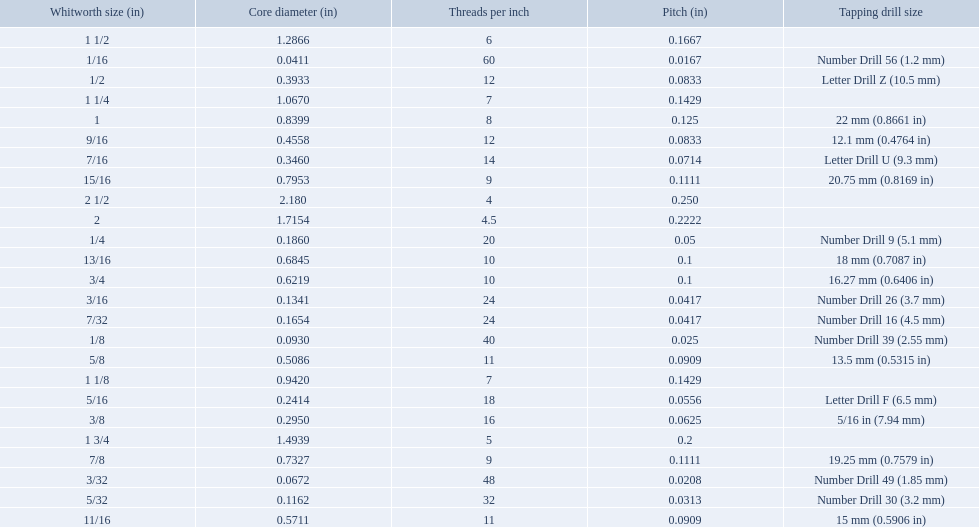What is the core diameter for the number drill 26? 0.1341. What is the whitworth size (in) for this core diameter? 3/16. Parse the full table in json format. {'header': ['Whitworth size (in)', 'Core diameter (in)', 'Threads per\xa0inch', 'Pitch (in)', 'Tapping drill size'], 'rows': [['1 1/2', '1.2866', '6', '0.1667', ''], ['1/16', '0.0411', '60', '0.0167', 'Number Drill 56 (1.2\xa0mm)'], ['1/2', '0.3933', '12', '0.0833', 'Letter Drill Z (10.5\xa0mm)'], ['1 1/4', '1.0670', '7', '0.1429', ''], ['1', '0.8399', '8', '0.125', '22\xa0mm (0.8661\xa0in)'], ['9/16', '0.4558', '12', '0.0833', '12.1\xa0mm (0.4764\xa0in)'], ['7/16', '0.3460', '14', '0.0714', 'Letter Drill U (9.3\xa0mm)'], ['15/16', '0.7953', '9', '0.1111', '20.75\xa0mm (0.8169\xa0in)'], ['2 1/2', '2.180', '4', '0.250', ''], ['2', '1.7154', '4.5', '0.2222', ''], ['1/4', '0.1860', '20', '0.05', 'Number Drill 9 (5.1\xa0mm)'], ['13/16', '0.6845', '10', '0.1', '18\xa0mm (0.7087\xa0in)'], ['3/4', '0.6219', '10', '0.1', '16.27\xa0mm (0.6406\xa0in)'], ['3/16', '0.1341', '24', '0.0417', 'Number Drill 26 (3.7\xa0mm)'], ['7/32', '0.1654', '24', '0.0417', 'Number Drill 16 (4.5\xa0mm)'], ['1/8', '0.0930', '40', '0.025', 'Number Drill 39 (2.55\xa0mm)'], ['5/8', '0.5086', '11', '0.0909', '13.5\xa0mm (0.5315\xa0in)'], ['1 1/8', '0.9420', '7', '0.1429', ''], ['5/16', '0.2414', '18', '0.0556', 'Letter Drill F (6.5\xa0mm)'], ['3/8', '0.2950', '16', '0.0625', '5/16\xa0in (7.94\xa0mm)'], ['1 3/4', '1.4939', '5', '0.2', ''], ['7/8', '0.7327', '9', '0.1111', '19.25\xa0mm (0.7579\xa0in)'], ['3/32', '0.0672', '48', '0.0208', 'Number Drill 49 (1.85\xa0mm)'], ['5/32', '0.1162', '32', '0.0313', 'Number Drill 30 (3.2\xa0mm)'], ['11/16', '0.5711', '11', '0.0909', '15\xa0mm (0.5906\xa0in)']]} What are all the whitworth sizes? 1/16, 3/32, 1/8, 5/32, 3/16, 7/32, 1/4, 5/16, 3/8, 7/16, 1/2, 9/16, 5/8, 11/16, 3/4, 13/16, 7/8, 15/16, 1, 1 1/8, 1 1/4, 1 1/2, 1 3/4, 2, 2 1/2. What are the threads per inch of these sizes? 60, 48, 40, 32, 24, 24, 20, 18, 16, 14, 12, 12, 11, 11, 10, 10, 9, 9, 8, 7, 7, 6, 5, 4.5, 4. Of these, which are 5? 5. What whitworth size has this threads per inch? 1 3/4. 